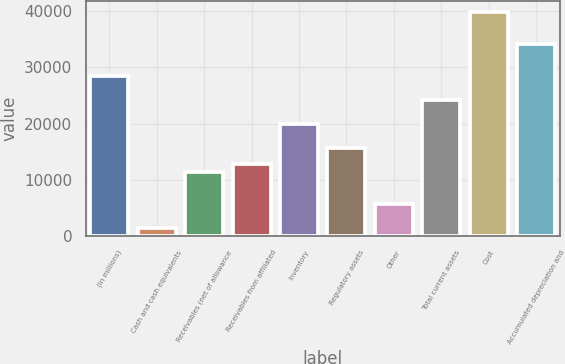Convert chart. <chart><loc_0><loc_0><loc_500><loc_500><bar_chart><fcel>(in millions)<fcel>Cash and cash equivalents<fcel>Receivables (net of allowance<fcel>Receivables from affiliated<fcel>Inventory<fcel>Regulatory assets<fcel>Other<fcel>Total current assets<fcel>Cost<fcel>Accumulated depreciation and<nl><fcel>28479<fcel>1426.8<fcel>11393.4<fcel>12817.2<fcel>19936.2<fcel>15664.8<fcel>5698.2<fcel>24207.6<fcel>39869.4<fcel>34174.2<nl></chart> 